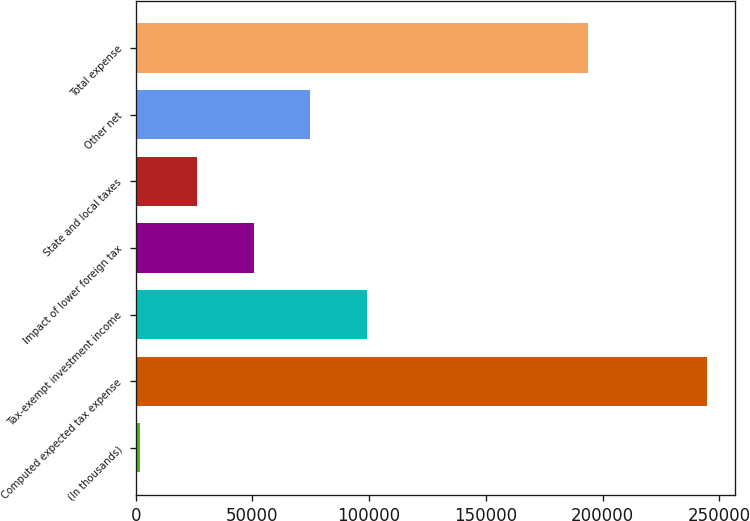Convert chart. <chart><loc_0><loc_0><loc_500><loc_500><bar_chart><fcel>(In thousands)<fcel>Computed expected tax expense<fcel>Tax-exempt investment income<fcel>Impact of lower foreign tax<fcel>State and local taxes<fcel>Other net<fcel>Total expense<nl><fcel>2013<fcel>244611<fcel>99052.2<fcel>50532.6<fcel>26272.8<fcel>74792.4<fcel>193587<nl></chart> 